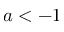Convert formula to latex. <formula><loc_0><loc_0><loc_500><loc_500>a < - 1</formula> 